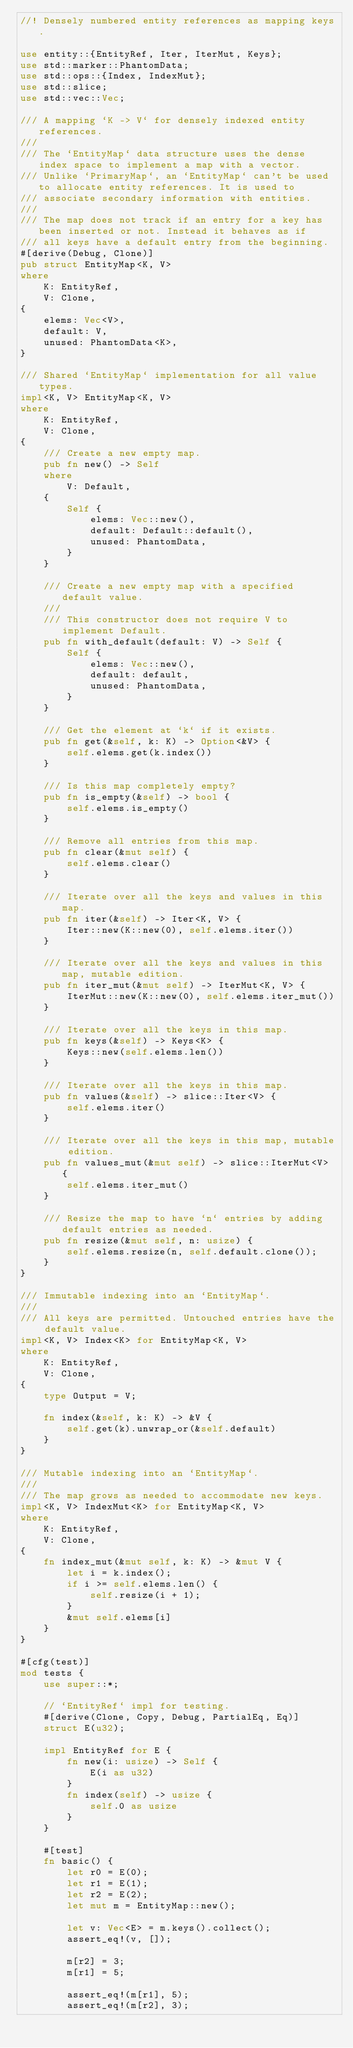Convert code to text. <code><loc_0><loc_0><loc_500><loc_500><_Rust_>//! Densely numbered entity references as mapping keys.

use entity::{EntityRef, Iter, IterMut, Keys};
use std::marker::PhantomData;
use std::ops::{Index, IndexMut};
use std::slice;
use std::vec::Vec;

/// A mapping `K -> V` for densely indexed entity references.
///
/// The `EntityMap` data structure uses the dense index space to implement a map with a vector.
/// Unlike `PrimaryMap`, an `EntityMap` can't be used to allocate entity references. It is used to
/// associate secondary information with entities.
///
/// The map does not track if an entry for a key has been inserted or not. Instead it behaves as if
/// all keys have a default entry from the beginning.
#[derive(Debug, Clone)]
pub struct EntityMap<K, V>
where
    K: EntityRef,
    V: Clone,
{
    elems: Vec<V>,
    default: V,
    unused: PhantomData<K>,
}

/// Shared `EntityMap` implementation for all value types.
impl<K, V> EntityMap<K, V>
where
    K: EntityRef,
    V: Clone,
{
    /// Create a new empty map.
    pub fn new() -> Self
    where
        V: Default,
    {
        Self {
            elems: Vec::new(),
            default: Default::default(),
            unused: PhantomData,
        }
    }

    /// Create a new empty map with a specified default value.
    ///
    /// This constructor does not require V to implement Default.
    pub fn with_default(default: V) -> Self {
        Self {
            elems: Vec::new(),
            default: default,
            unused: PhantomData,
        }
    }

    /// Get the element at `k` if it exists.
    pub fn get(&self, k: K) -> Option<&V> {
        self.elems.get(k.index())
    }

    /// Is this map completely empty?
    pub fn is_empty(&self) -> bool {
        self.elems.is_empty()
    }

    /// Remove all entries from this map.
    pub fn clear(&mut self) {
        self.elems.clear()
    }

    /// Iterate over all the keys and values in this map.
    pub fn iter(&self) -> Iter<K, V> {
        Iter::new(K::new(0), self.elems.iter())
    }

    /// Iterate over all the keys and values in this map, mutable edition.
    pub fn iter_mut(&mut self) -> IterMut<K, V> {
        IterMut::new(K::new(0), self.elems.iter_mut())
    }

    /// Iterate over all the keys in this map.
    pub fn keys(&self) -> Keys<K> {
        Keys::new(self.elems.len())
    }

    /// Iterate over all the keys in this map.
    pub fn values(&self) -> slice::Iter<V> {
        self.elems.iter()
    }

    /// Iterate over all the keys in this map, mutable edition.
    pub fn values_mut(&mut self) -> slice::IterMut<V> {
        self.elems.iter_mut()
    }

    /// Resize the map to have `n` entries by adding default entries as needed.
    pub fn resize(&mut self, n: usize) {
        self.elems.resize(n, self.default.clone());
    }
}

/// Immutable indexing into an `EntityMap`.
///
/// All keys are permitted. Untouched entries have the default value.
impl<K, V> Index<K> for EntityMap<K, V>
where
    K: EntityRef,
    V: Clone,
{
    type Output = V;

    fn index(&self, k: K) -> &V {
        self.get(k).unwrap_or(&self.default)
    }
}

/// Mutable indexing into an `EntityMap`.
///
/// The map grows as needed to accommodate new keys.
impl<K, V> IndexMut<K> for EntityMap<K, V>
where
    K: EntityRef,
    V: Clone,
{
    fn index_mut(&mut self, k: K) -> &mut V {
        let i = k.index();
        if i >= self.elems.len() {
            self.resize(i + 1);
        }
        &mut self.elems[i]
    }
}

#[cfg(test)]
mod tests {
    use super::*;

    // `EntityRef` impl for testing.
    #[derive(Clone, Copy, Debug, PartialEq, Eq)]
    struct E(u32);

    impl EntityRef for E {
        fn new(i: usize) -> Self {
            E(i as u32)
        }
        fn index(self) -> usize {
            self.0 as usize
        }
    }

    #[test]
    fn basic() {
        let r0 = E(0);
        let r1 = E(1);
        let r2 = E(2);
        let mut m = EntityMap::new();

        let v: Vec<E> = m.keys().collect();
        assert_eq!(v, []);

        m[r2] = 3;
        m[r1] = 5;

        assert_eq!(m[r1], 5);
        assert_eq!(m[r2], 3);
</code> 